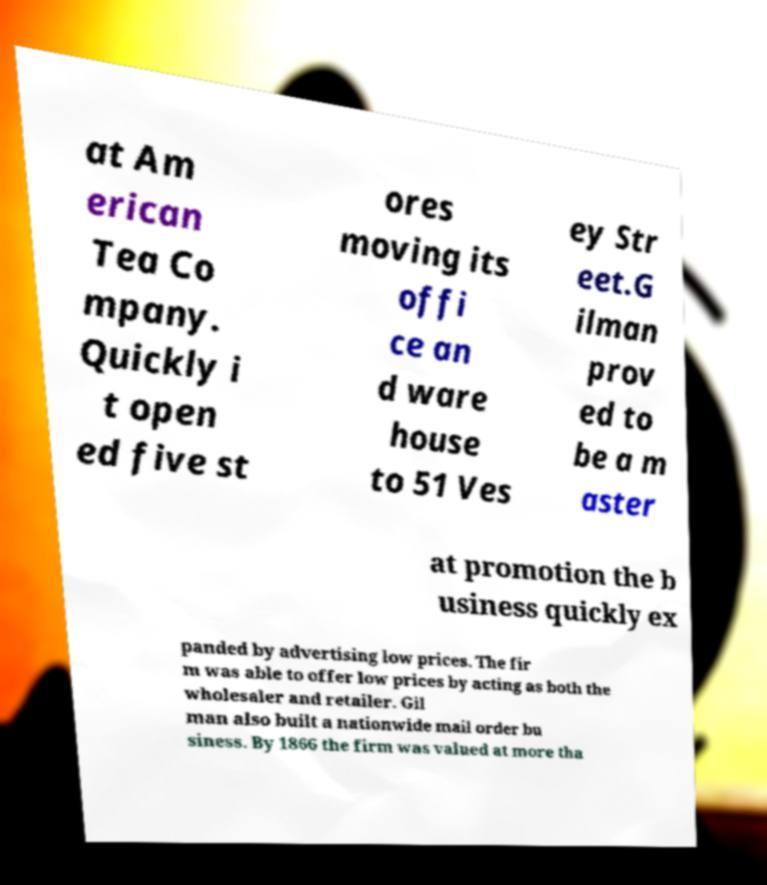Could you extract and type out the text from this image? at Am erican Tea Co mpany. Quickly i t open ed five st ores moving its offi ce an d ware house to 51 Ves ey Str eet.G ilman prov ed to be a m aster at promotion the b usiness quickly ex panded by advertising low prices. The fir m was able to offer low prices by acting as both the wholesaler and retailer. Gil man also built a nationwide mail order bu siness. By 1866 the firm was valued at more tha 